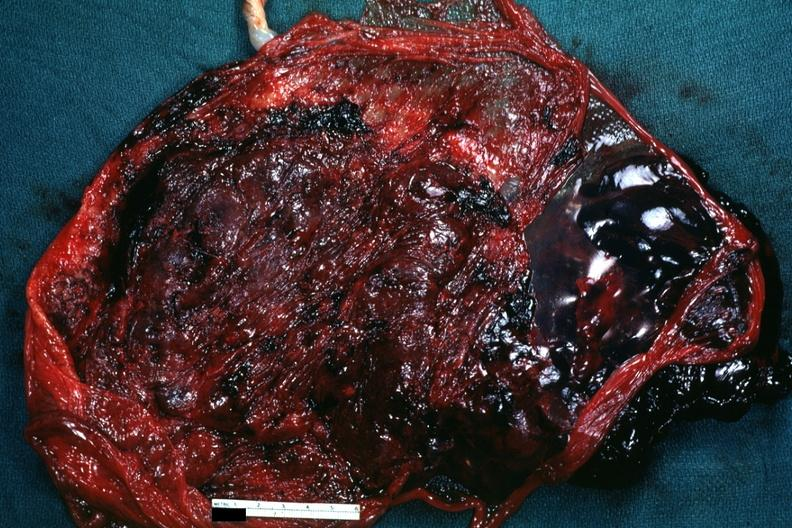s focal hemorrhagic infarction well shown present?
Answer the question using a single word or phrase. No 